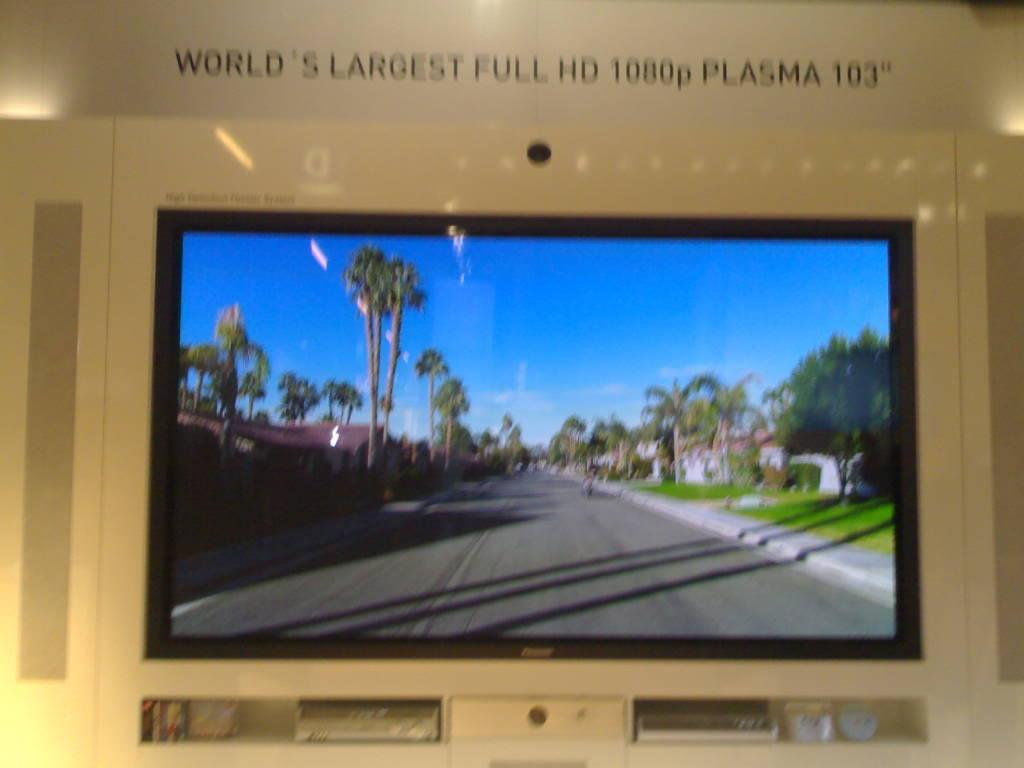<image>
Relay a brief, clear account of the picture shown. the word largest that is above a television 